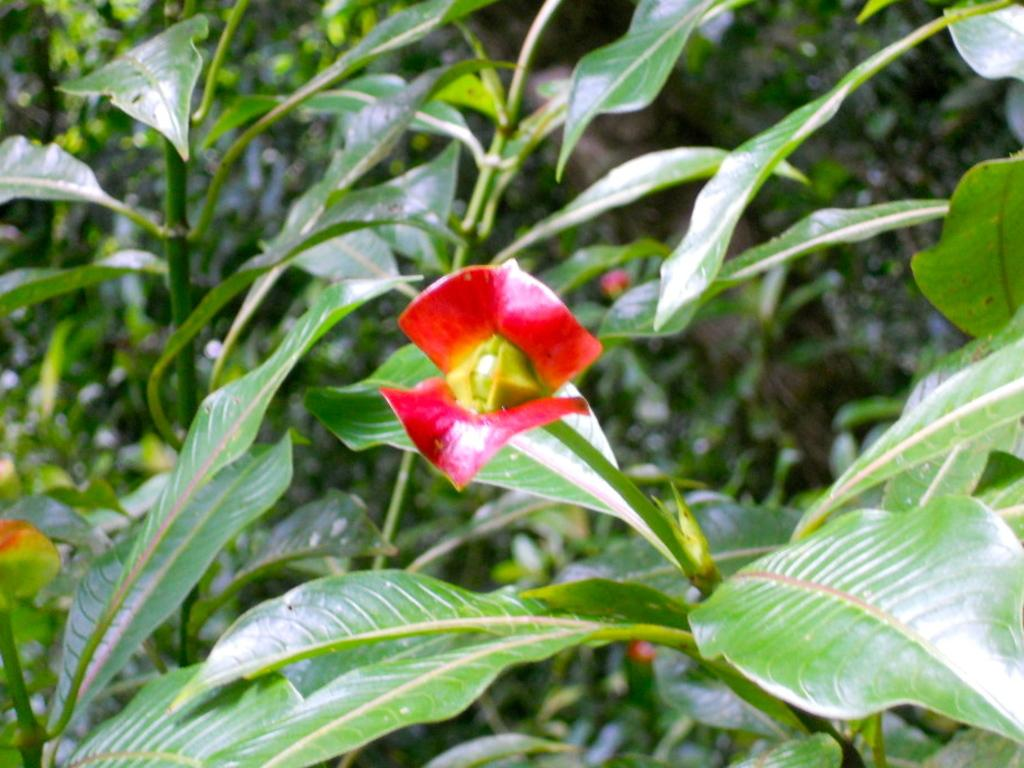What type of living organisms can be seen in the image? Plants and a flower are visible in the image. Can you describe the flower in the image? There is a flower in the image, but its specific characteristics are not mentioned in the facts. What is the condition of the background in the image? The background of the image is blurred. What type of turkey can be seen in the image? There is no turkey present in the image; it features plants and a flower. Is there a band playing music in the image? There is no band or any indication of music in the image. 